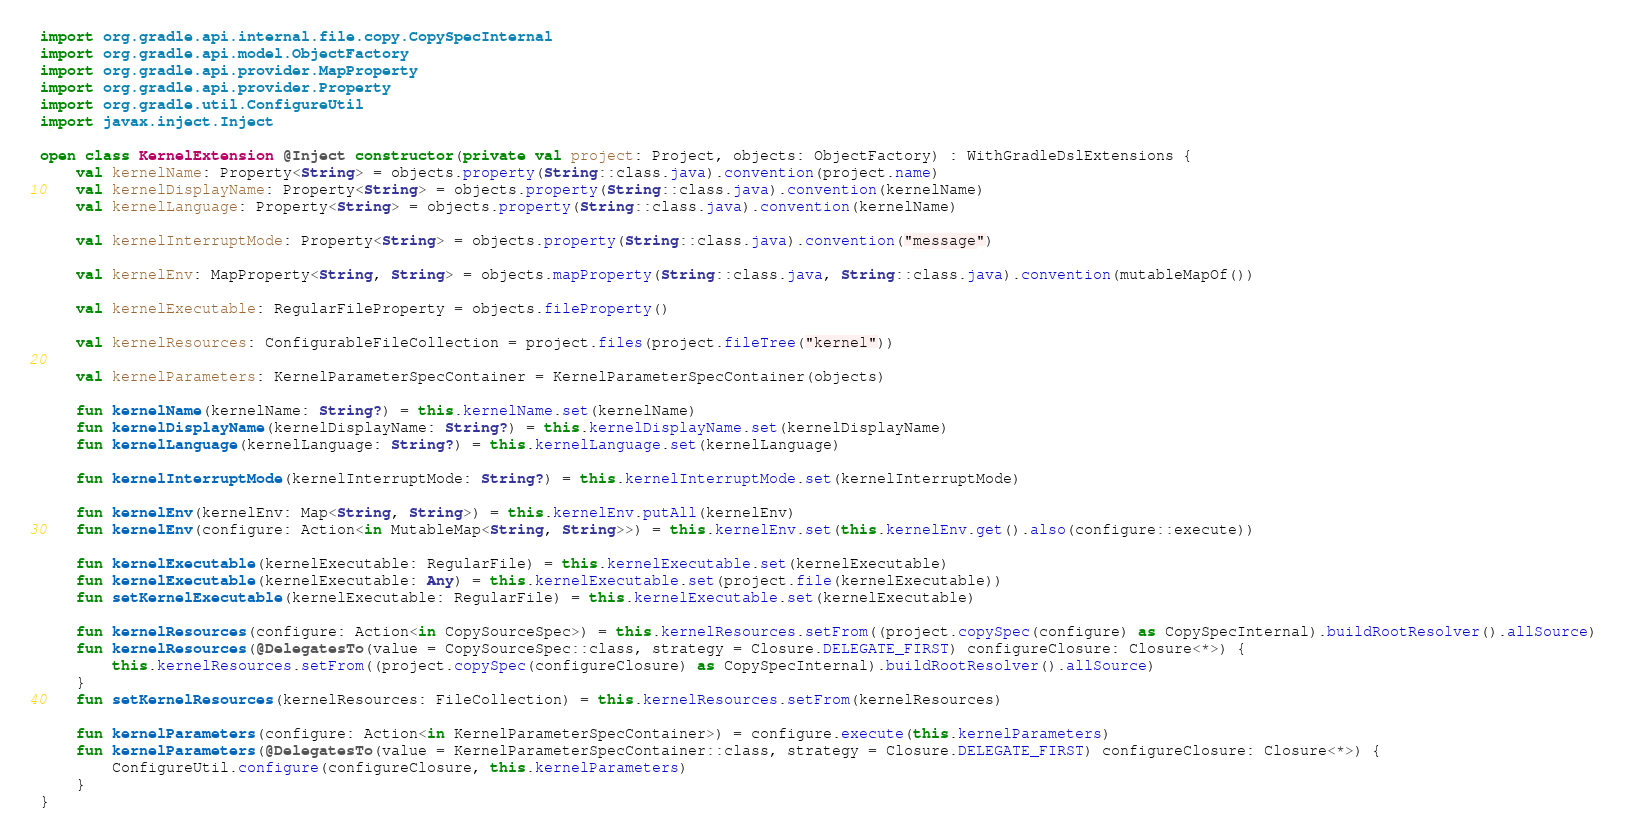Convert code to text. <code><loc_0><loc_0><loc_500><loc_500><_Kotlin_>import org.gradle.api.internal.file.copy.CopySpecInternal
import org.gradle.api.model.ObjectFactory
import org.gradle.api.provider.MapProperty
import org.gradle.api.provider.Property
import org.gradle.util.ConfigureUtil
import javax.inject.Inject

open class KernelExtension @Inject constructor(private val project: Project, objects: ObjectFactory) : WithGradleDslExtensions {
    val kernelName: Property<String> = objects.property(String::class.java).convention(project.name)
    val kernelDisplayName: Property<String> = objects.property(String::class.java).convention(kernelName)
    val kernelLanguage: Property<String> = objects.property(String::class.java).convention(kernelName)

    val kernelInterruptMode: Property<String> = objects.property(String::class.java).convention("message")

    val kernelEnv: MapProperty<String, String> = objects.mapProperty(String::class.java, String::class.java).convention(mutableMapOf())

    val kernelExecutable: RegularFileProperty = objects.fileProperty()

    val kernelResources: ConfigurableFileCollection = project.files(project.fileTree("kernel"))

    val kernelParameters: KernelParameterSpecContainer = KernelParameterSpecContainer(objects)

    fun kernelName(kernelName: String?) = this.kernelName.set(kernelName)
    fun kernelDisplayName(kernelDisplayName: String?) = this.kernelDisplayName.set(kernelDisplayName)
    fun kernelLanguage(kernelLanguage: String?) = this.kernelLanguage.set(kernelLanguage)

    fun kernelInterruptMode(kernelInterruptMode: String?) = this.kernelInterruptMode.set(kernelInterruptMode)

    fun kernelEnv(kernelEnv: Map<String, String>) = this.kernelEnv.putAll(kernelEnv)
    fun kernelEnv(configure: Action<in MutableMap<String, String>>) = this.kernelEnv.set(this.kernelEnv.get().also(configure::execute))

    fun kernelExecutable(kernelExecutable: RegularFile) = this.kernelExecutable.set(kernelExecutable)
    fun kernelExecutable(kernelExecutable: Any) = this.kernelExecutable.set(project.file(kernelExecutable))
    fun setKernelExecutable(kernelExecutable: RegularFile) = this.kernelExecutable.set(kernelExecutable)

    fun kernelResources(configure: Action<in CopySourceSpec>) = this.kernelResources.setFrom((project.copySpec(configure) as CopySpecInternal).buildRootResolver().allSource)
    fun kernelResources(@DelegatesTo(value = CopySourceSpec::class, strategy = Closure.DELEGATE_FIRST) configureClosure: Closure<*>) {
        this.kernelResources.setFrom((project.copySpec(configureClosure) as CopySpecInternal).buildRootResolver().allSource)
    }
    fun setKernelResources(kernelResources: FileCollection) = this.kernelResources.setFrom(kernelResources)

    fun kernelParameters(configure: Action<in KernelParameterSpecContainer>) = configure.execute(this.kernelParameters)
    fun kernelParameters(@DelegatesTo(value = KernelParameterSpecContainer::class, strategy = Closure.DELEGATE_FIRST) configureClosure: Closure<*>) {
        ConfigureUtil.configure(configureClosure, this.kernelParameters)
    }
}</code> 